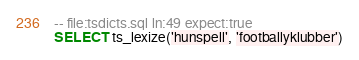Convert code to text. <code><loc_0><loc_0><loc_500><loc_500><_SQL_>-- file:tsdicts.sql ln:49 expect:true
SELECT ts_lexize('hunspell', 'footballyklubber')
</code> 